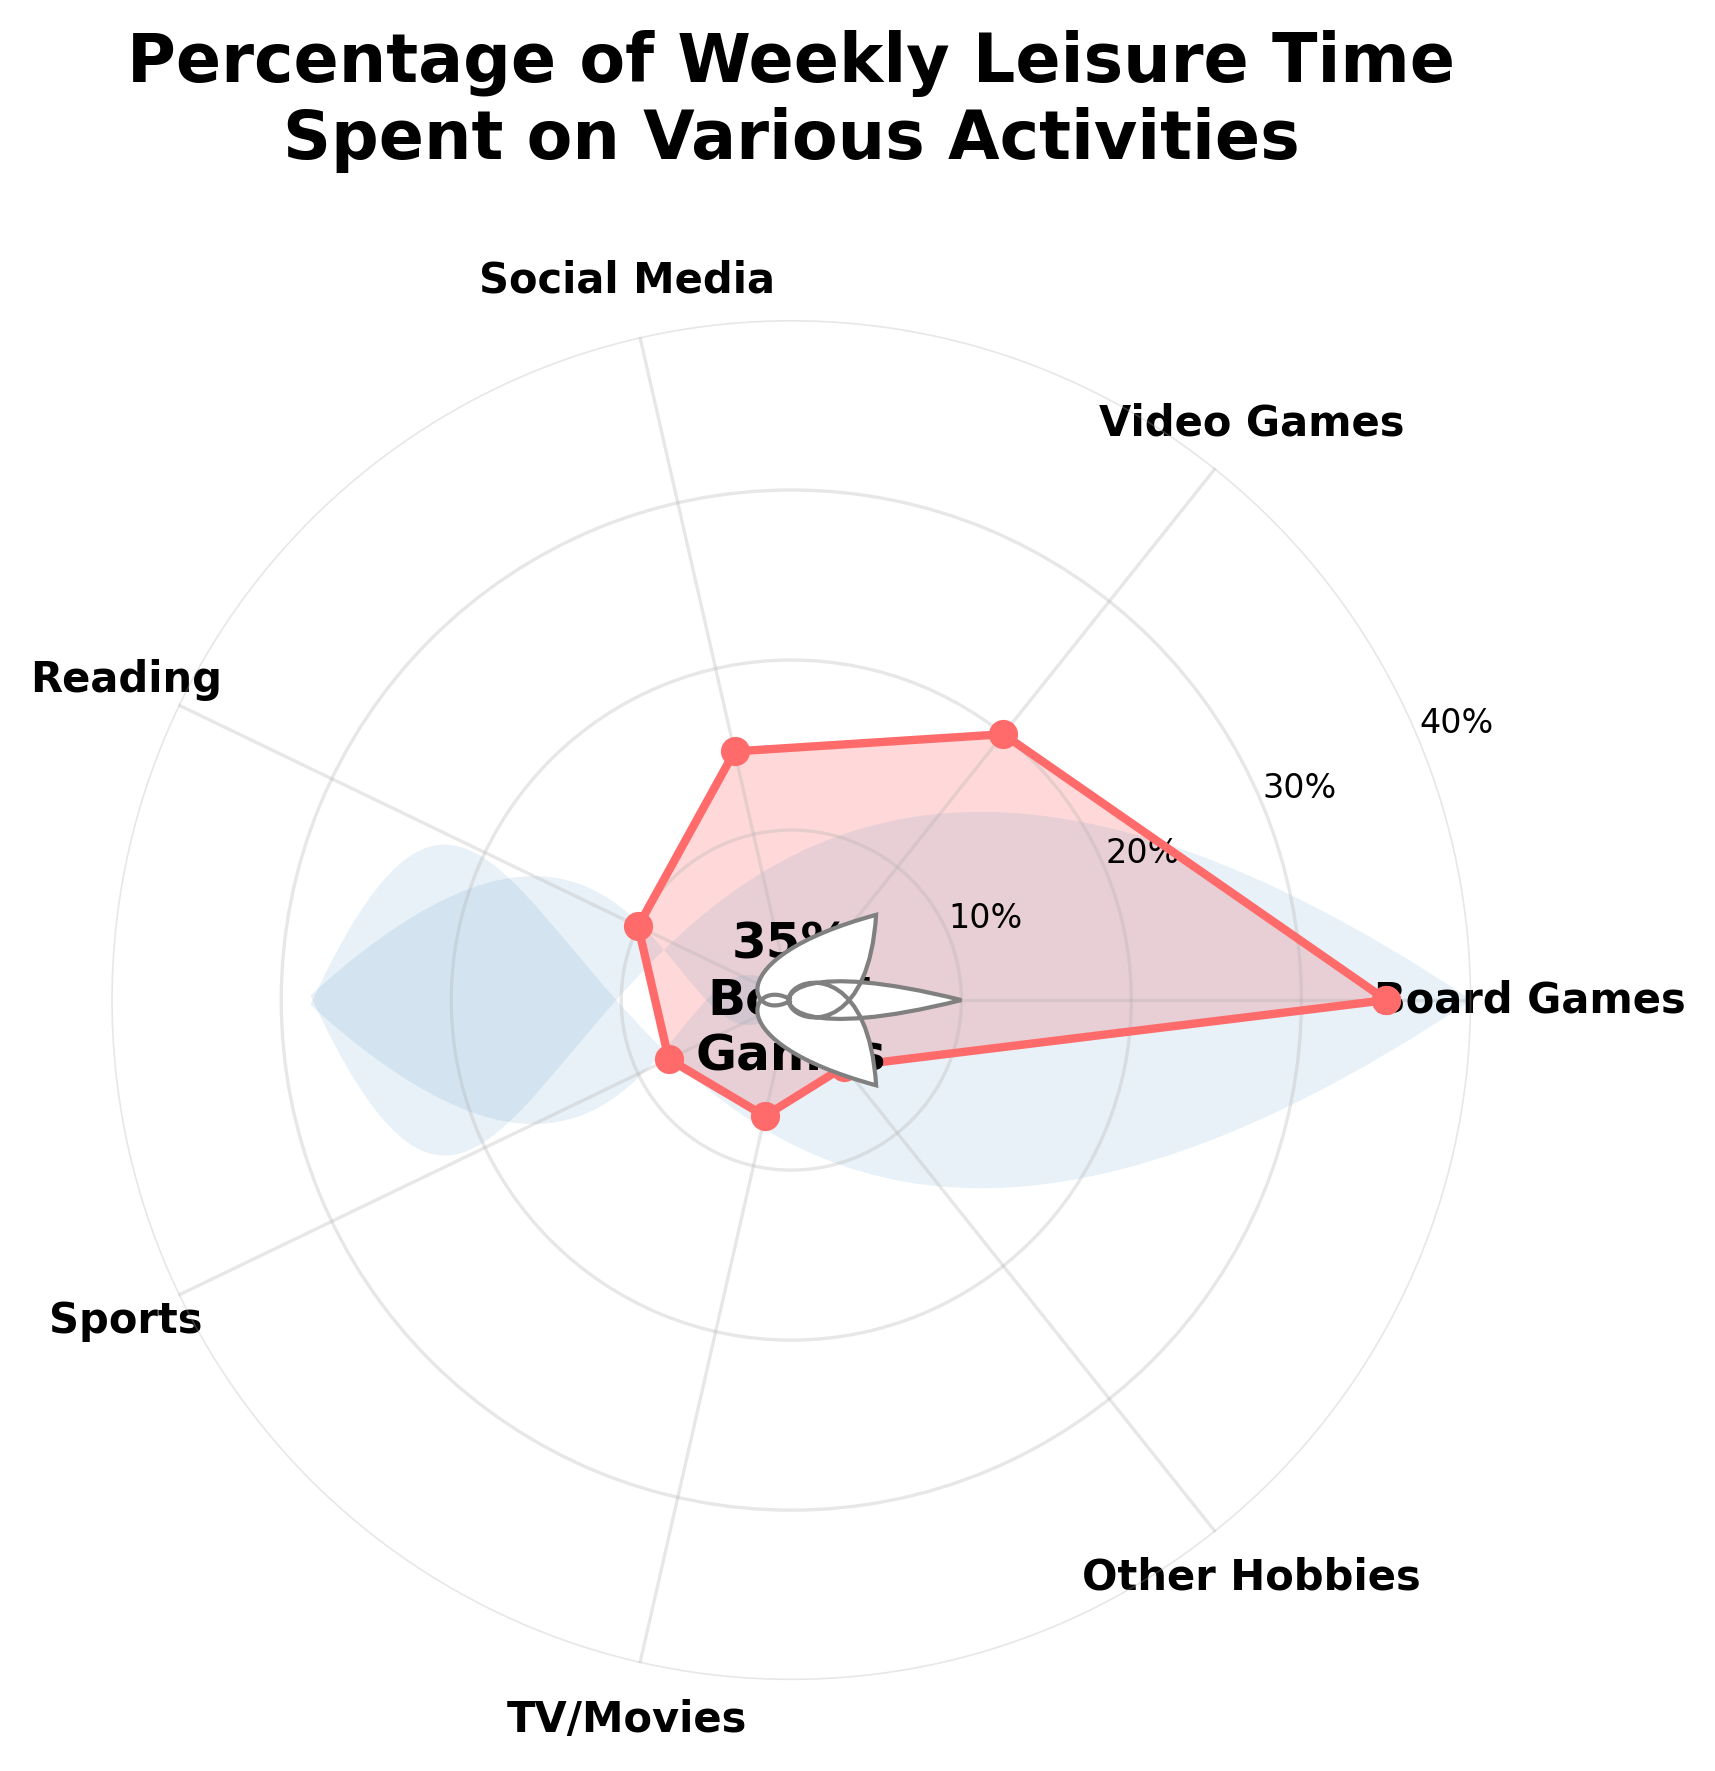How much percentage of weekly leisure time is spent on board games? According to the figure, the central text indicates that 35% of weekly leisure time is spent on board games.
Answer: 35% Which activity occupies the second highest percentage of weekly leisure time? By looking at the plotted data, the second highest percentage after board games is for video games.
Answer: Video Games What's the combined percentage of weekly leisure time spent on sports and TV/movies? Sports take 8% and TV/movies take 7%. Summing these gives 8% + 7% = 15%.
Answer: 15% How does the time spent on social media compare to reading? The chart shows that 15% is spent on social media and 10% on reading. Therefore, more time is spent on social media than on reading.
Answer: More on Social Media Are sports and other hobbies combined accounting for more or less than reading? Sports are at 8% and other hobbies at 5%, summing up to 13%. Reading is at 10%, so sports and other hobbies combined account for more.
Answer: More Which activity has the least percentage, and what is it? The radial distance on the gauge chart is smallest for "Other Hobbies", indicating it has the least percentage of 5%.
Answer: Other Hobbies, 5% What is the difference in percentage between time spent on video games and reading? The percentage for video games is 20% and for reading is 10%. The difference is 20% - 10% = 10%.
Answer: 10% Comparing the social media and sports activities, which one has a larger percentage, and by how much? The chart shows social media at 15% and sports at 8%. The difference is 15% - 8% = 7%, with social media being larger.
Answer: Social Media, 7% What is the average percentage of time spent on all activities excluding board games? To find the average, sum all percentages excluding board games (20 + 15 + 10 + 8 + 7 + 5 = 65). Since there are 6 activities, the average is 65%/6 ≈ 10.83%.
Answer: 10.83% What percentage range is the highest marked on the y-axis, and which activity reaches this range? The highest marked range on the y-axis is 30% to 40%. Only board games reach this range, marked at 35%.
Answer: 30%-40%, Board Games 